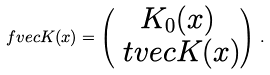Convert formula to latex. <formula><loc_0><loc_0><loc_500><loc_500>\ f v e c { K } ( x ) = \begin{pmatrix} K _ { 0 } ( x ) \\ \ t v e c { K } ( x ) \end{pmatrix} \, .</formula> 